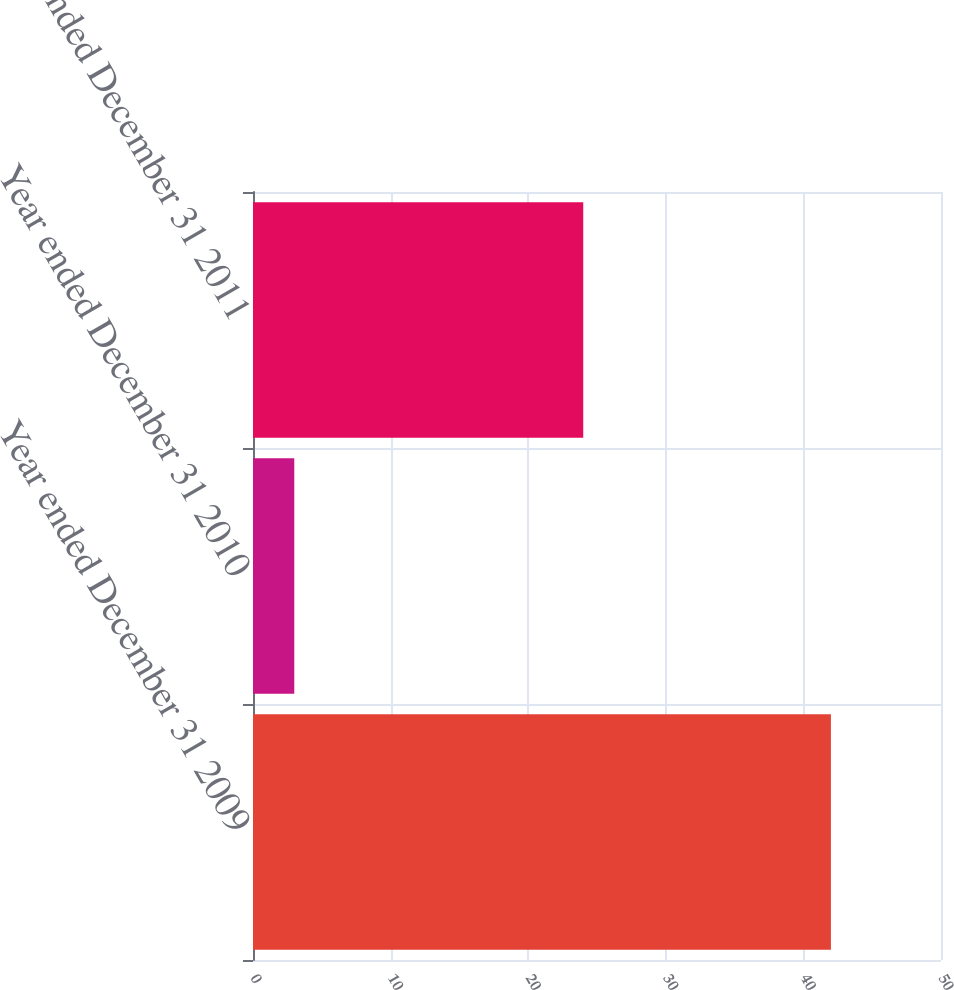Convert chart to OTSL. <chart><loc_0><loc_0><loc_500><loc_500><bar_chart><fcel>Year ended December 31 2009<fcel>Year ended December 31 2010<fcel>Year ended December 31 2011<nl><fcel>42<fcel>3<fcel>24<nl></chart> 